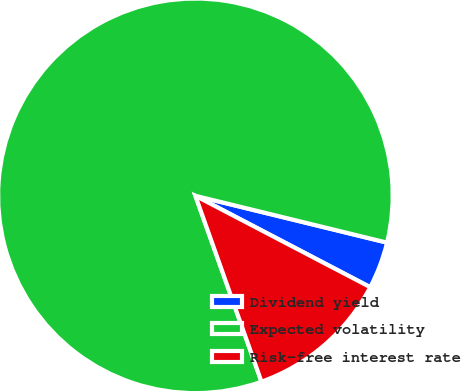Convert chart to OTSL. <chart><loc_0><loc_0><loc_500><loc_500><pie_chart><fcel>Dividend yield<fcel>Expected volatility<fcel>Risk-free interest rate<nl><fcel>3.85%<fcel>84.25%<fcel>11.9%<nl></chart> 